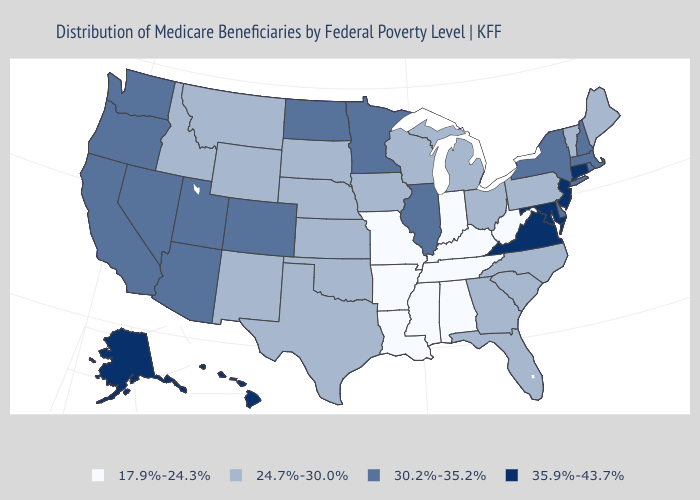What is the value of Connecticut?
Short answer required. 35.9%-43.7%. Does California have a higher value than New Jersey?
Write a very short answer. No. Name the states that have a value in the range 24.7%-30.0%?
Quick response, please. Florida, Georgia, Idaho, Iowa, Kansas, Maine, Michigan, Montana, Nebraska, New Mexico, North Carolina, Ohio, Oklahoma, Pennsylvania, South Carolina, South Dakota, Texas, Vermont, Wisconsin, Wyoming. Name the states that have a value in the range 30.2%-35.2%?
Quick response, please. Arizona, California, Colorado, Delaware, Illinois, Massachusetts, Minnesota, Nevada, New Hampshire, New York, North Dakota, Oregon, Rhode Island, Utah, Washington. Among the states that border Illinois , does Indiana have the lowest value?
Quick response, please. Yes. Is the legend a continuous bar?
Write a very short answer. No. Which states have the lowest value in the South?
Answer briefly. Alabama, Arkansas, Kentucky, Louisiana, Mississippi, Tennessee, West Virginia. Name the states that have a value in the range 24.7%-30.0%?
Concise answer only. Florida, Georgia, Idaho, Iowa, Kansas, Maine, Michigan, Montana, Nebraska, New Mexico, North Carolina, Ohio, Oklahoma, Pennsylvania, South Carolina, South Dakota, Texas, Vermont, Wisconsin, Wyoming. What is the lowest value in states that border Pennsylvania?
Quick response, please. 17.9%-24.3%. Among the states that border New Hampshire , which have the lowest value?
Concise answer only. Maine, Vermont. Name the states that have a value in the range 17.9%-24.3%?
Write a very short answer. Alabama, Arkansas, Indiana, Kentucky, Louisiana, Mississippi, Missouri, Tennessee, West Virginia. What is the value of Oklahoma?
Answer briefly. 24.7%-30.0%. What is the highest value in the USA?
Quick response, please. 35.9%-43.7%. What is the value of Tennessee?
Concise answer only. 17.9%-24.3%. Name the states that have a value in the range 30.2%-35.2%?
Quick response, please. Arizona, California, Colorado, Delaware, Illinois, Massachusetts, Minnesota, Nevada, New Hampshire, New York, North Dakota, Oregon, Rhode Island, Utah, Washington. 